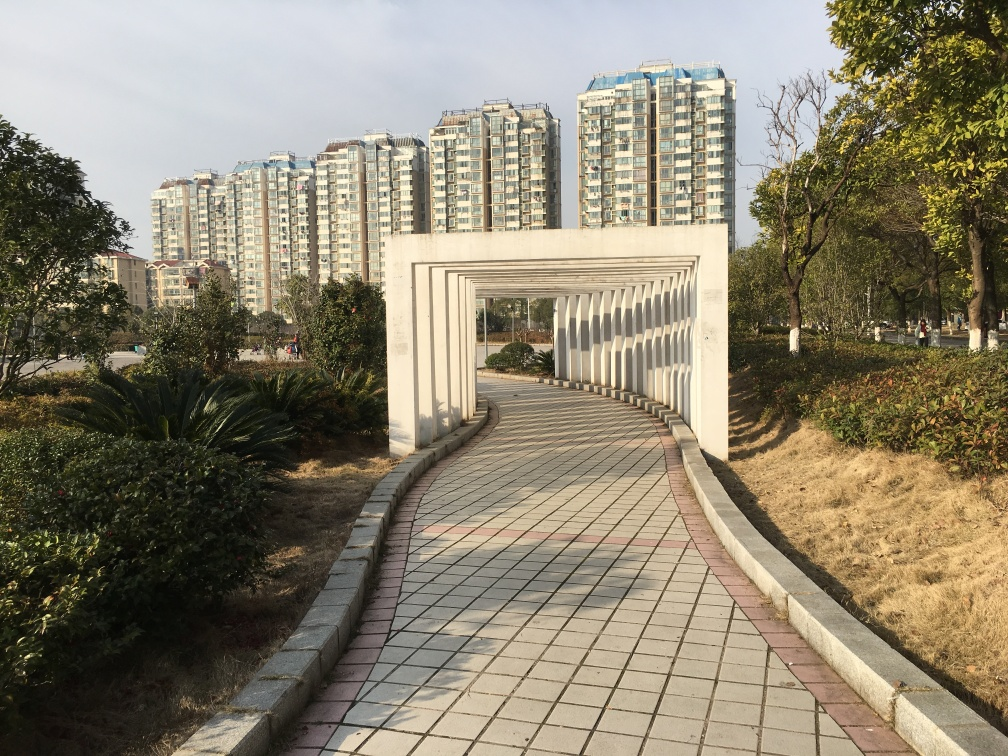Is the image visually appealing? Visual appeal is subjective, but the image presents a serene urban park with a unique rectangular archway leading to modern apartment buildings, which may be appealing for its orderly composition, contrasting structures, and inviting pathway. 